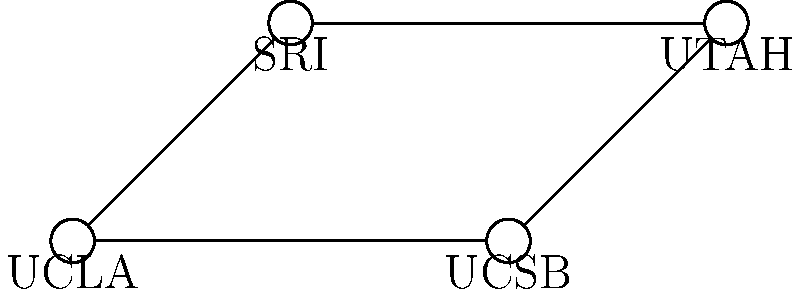In the early stages of ARPANET, what was the topology of the network connecting the first four nodes (UCLA, SRI, UCSB, and UTAH)? To determine the topology of the early ARPANET, let's analyze the connections step-by-step:

1. The diagram shows four nodes: UCLA, SRI, UCSB, and UTAH.
2. We can observe the following connections:
   - UCLA is connected to SRI and UCSB
   - SRI is connected to UCLA and UTAH
   - UCSB is connected to UCLA and UTAH
   - UTAH is connected to SRI and UCSB
3. Each node is connected to exactly two other nodes.
4. The connections form a closed loop, where data can travel from any node to any other node.
5. This arrangement creates a ring-like structure, where each node acts as both a host and a relay.
6. In network topology terms, this configuration is known as a "ring topology."

The ring topology was chosen for its reliability and efficiency in the early stages of ARPANET. It allowed for data to be transmitted in either direction around the ring, providing redundancy in case of a single link failure.
Answer: Ring topology 